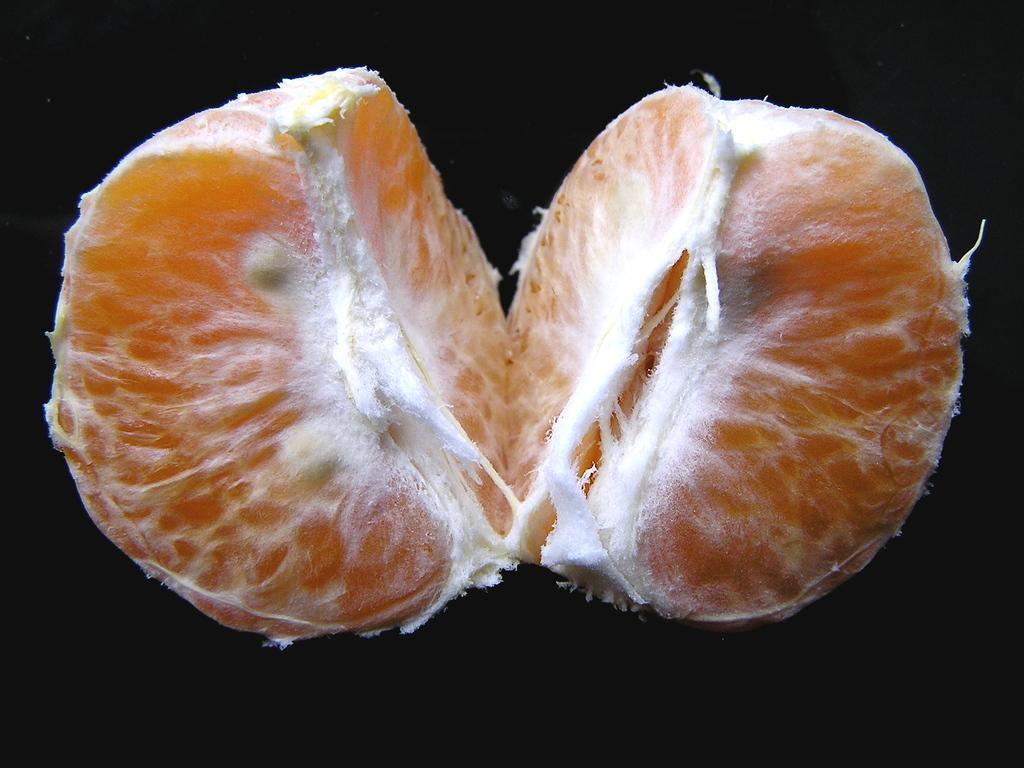Can you describe this image briefly? In this picture we can see there are two orange pieces. Behind the orange pieces, there is the dark background. 